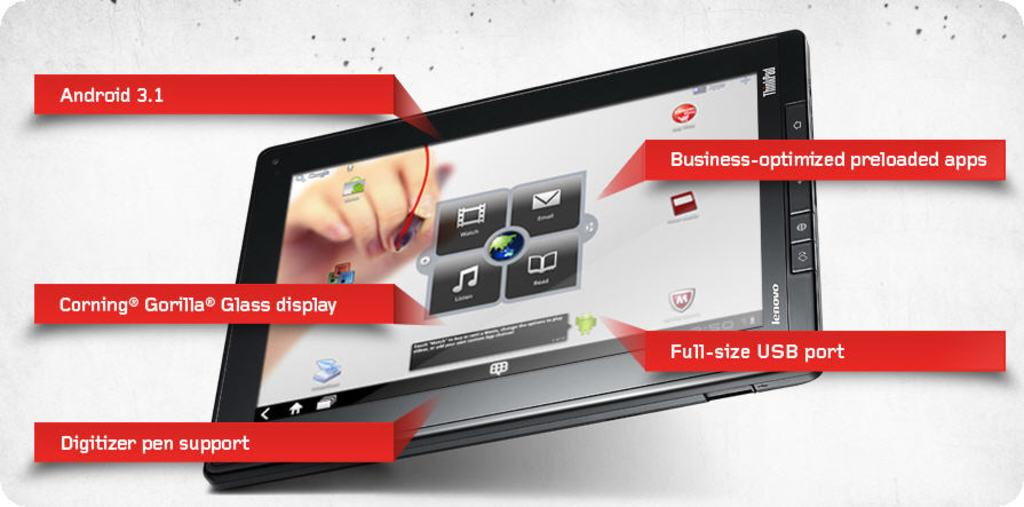<image>
Give a short and clear explanation of the subsequent image. the advertisement for the tablet shows a lot of things like a full sized usbport 